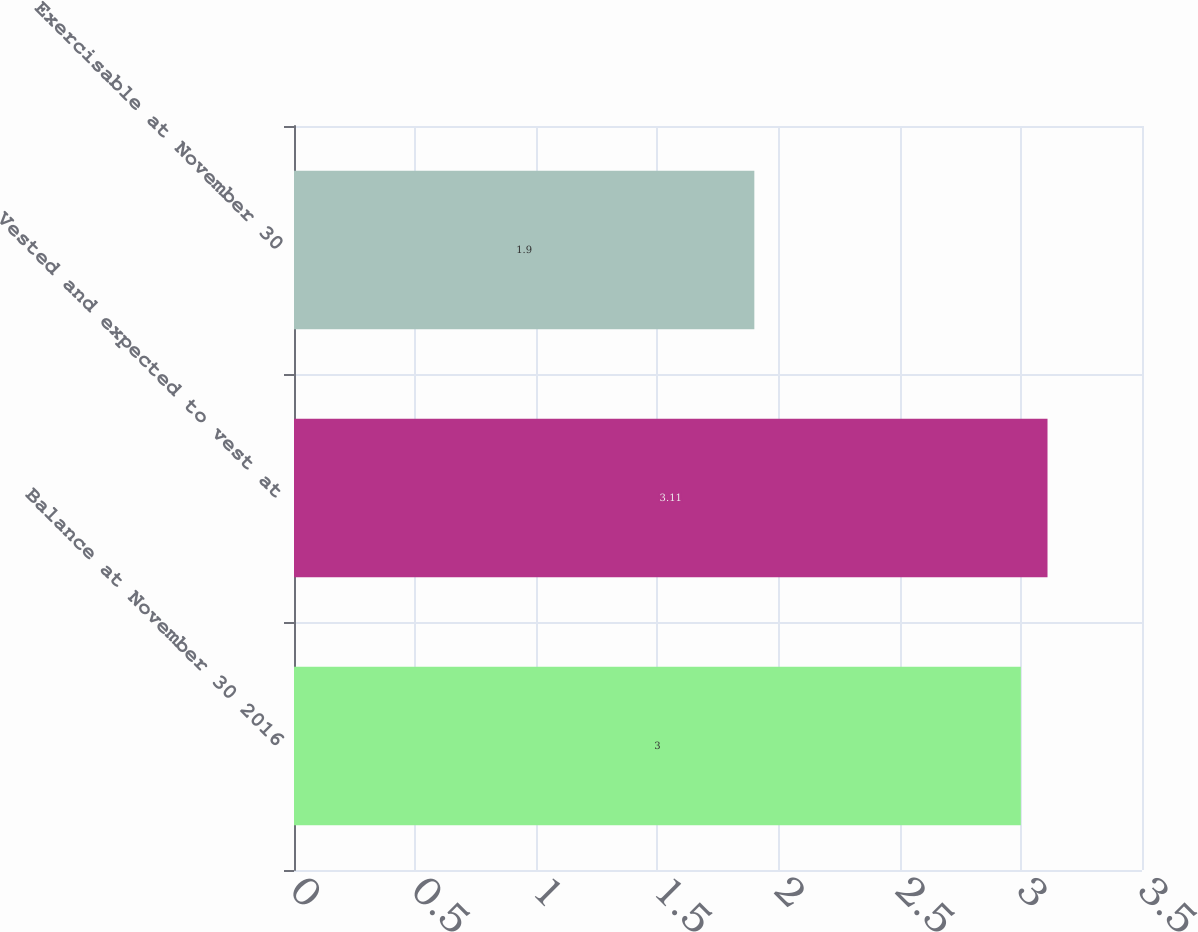<chart> <loc_0><loc_0><loc_500><loc_500><bar_chart><fcel>Balance at November 30 2016<fcel>Vested and expected to vest at<fcel>Exercisable at November 30<nl><fcel>3<fcel>3.11<fcel>1.9<nl></chart> 